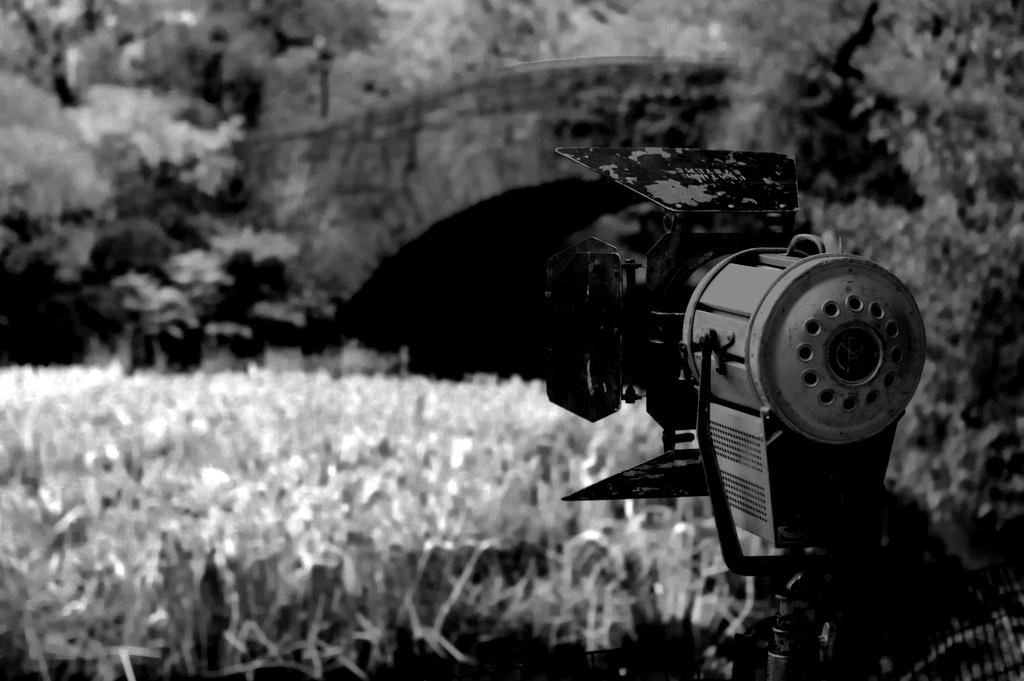What object in the image looks like a camera? There is an object that resembles a camera in the image. What can be seen in the background of the image? There are trees in the background of the image. What type of vegetation is visible in the image? There is grass visible in the image. What is the size of the brick in the image? There is no brick present in the image. What idea does the camera have in the image? The camera is an inanimate object and does not have any ideas. 